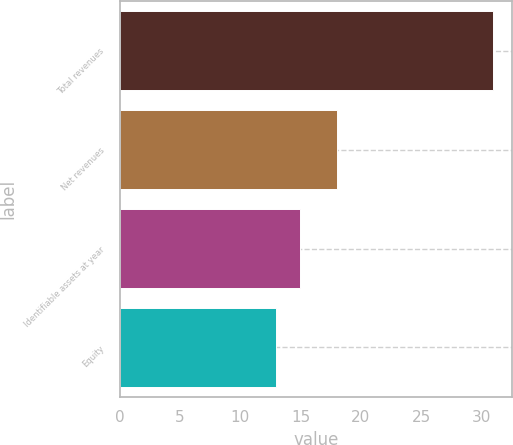Convert chart. <chart><loc_0><loc_0><loc_500><loc_500><bar_chart><fcel>Total revenues<fcel>Net revenues<fcel>Identifiable assets at year<fcel>Equity<nl><fcel>31<fcel>18<fcel>15<fcel>13<nl></chart> 